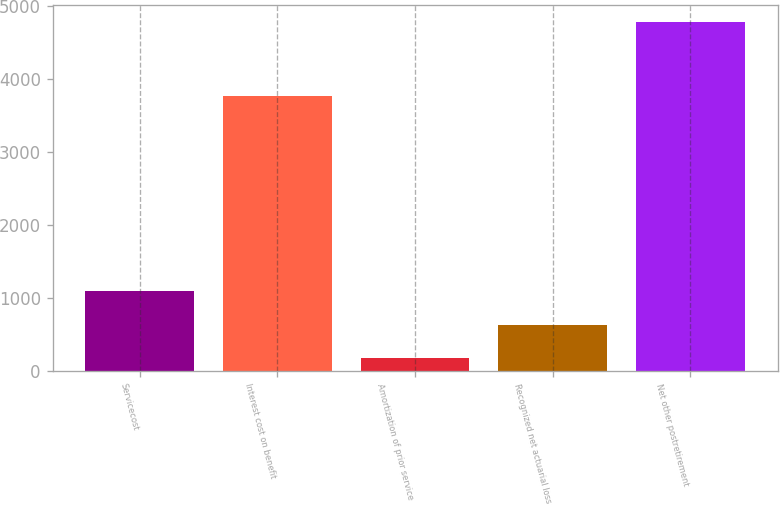<chart> <loc_0><loc_0><loc_500><loc_500><bar_chart><fcel>Servicecost<fcel>Interest cost on benefit<fcel>Amortization of prior service<fcel>Recognized net actuarial loss<fcel>Net other postretirement<nl><fcel>1092.6<fcel>3770<fcel>170<fcel>631.3<fcel>4783<nl></chart> 